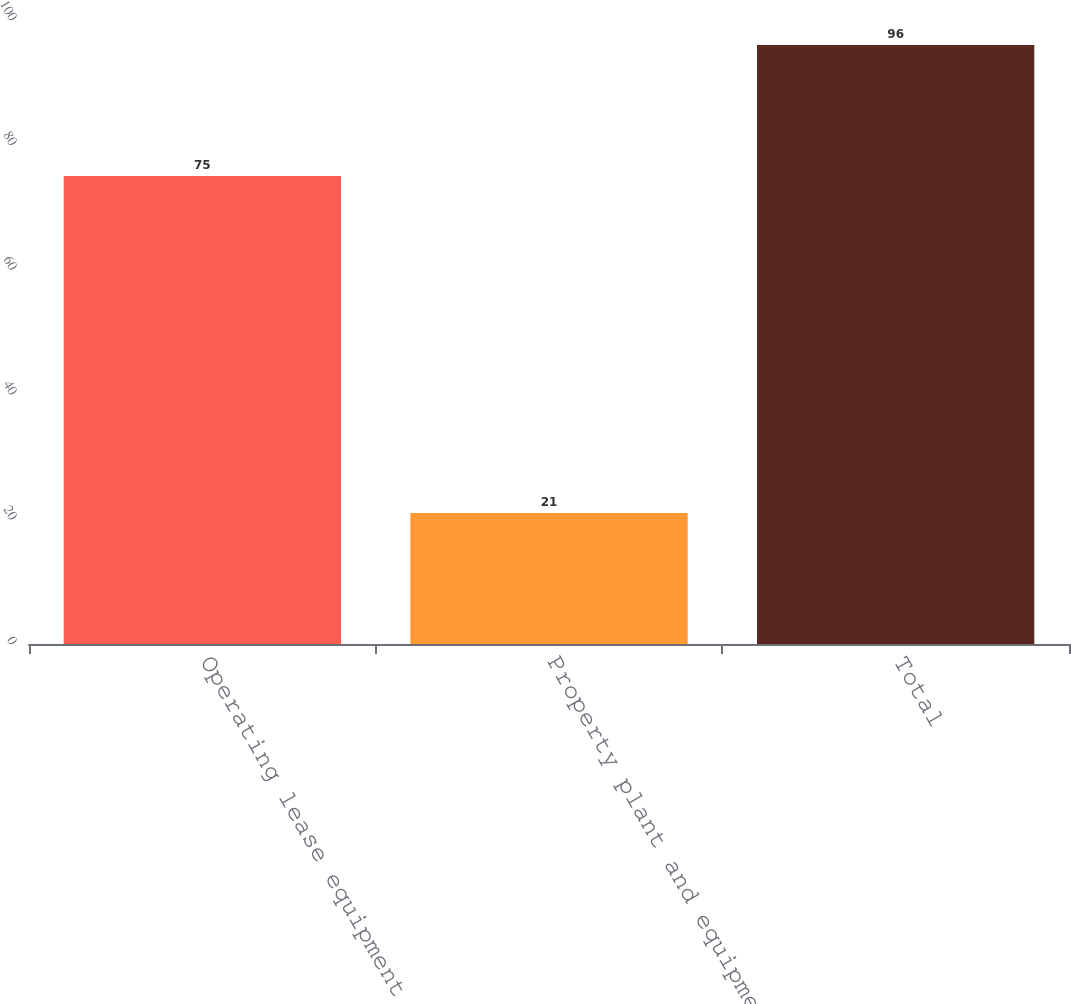Convert chart to OTSL. <chart><loc_0><loc_0><loc_500><loc_500><bar_chart><fcel>Operating lease equipment<fcel>Property plant and equipment<fcel>Total<nl><fcel>75<fcel>21<fcel>96<nl></chart> 